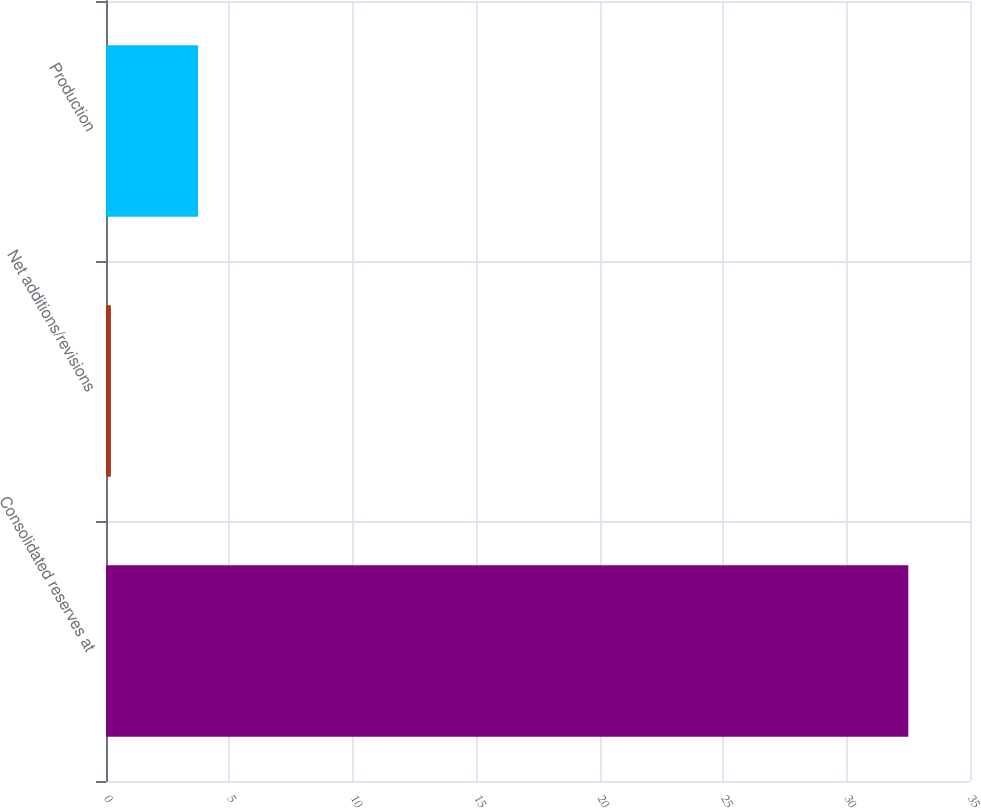Convert chart to OTSL. <chart><loc_0><loc_0><loc_500><loc_500><bar_chart><fcel>Consolidated reserves at<fcel>Net additions/revisions<fcel>Production<nl><fcel>32.5<fcel>0.2<fcel>3.73<nl></chart> 